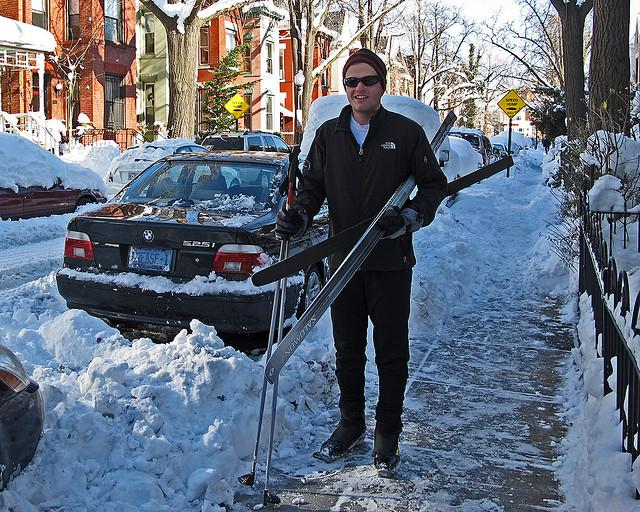How did this man get to this location immediately prior to taking this picture?

Choices:
A) skied
B) walked
C) flew
D) jogged walked 